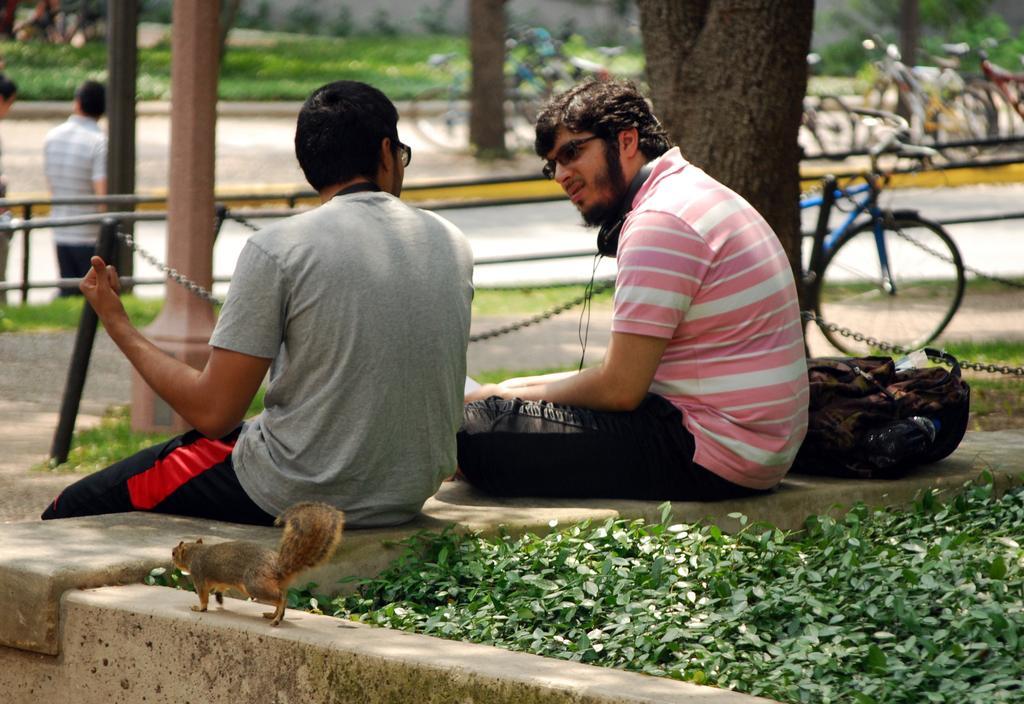Describe this image in one or two sentences. There are two men sitting on the wall. This looks like a squirrel. I think these are the plants with the leaves. This looks like a backpack bag. I think these are the poles. I can see a tree trunk. These are the bicycles, which are parked. I can see a person standing. In the background, that looks like a grass. 